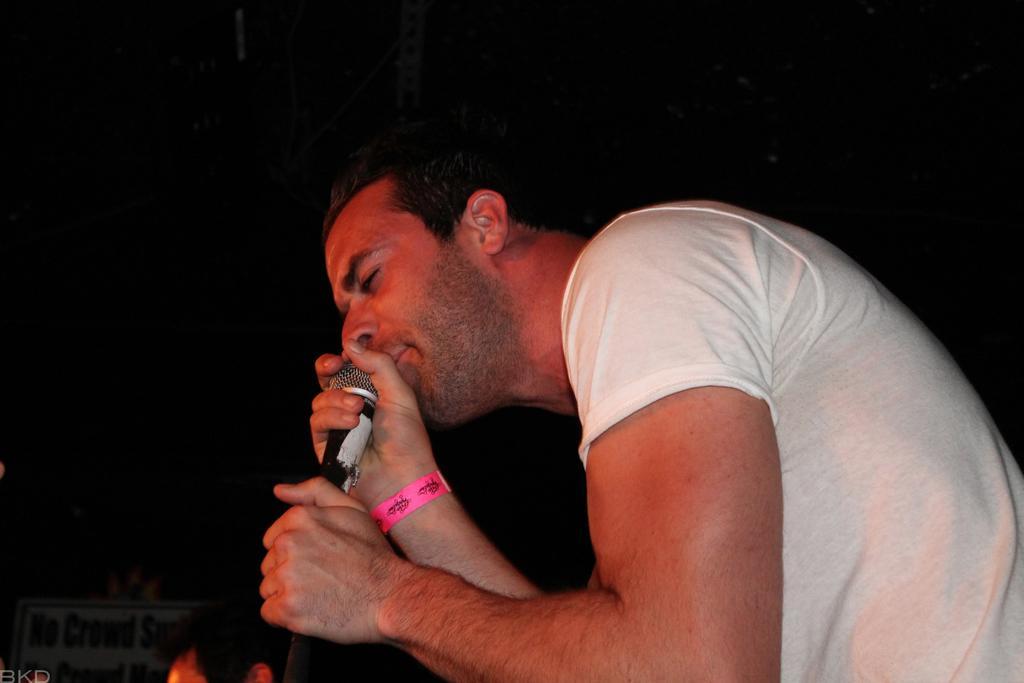How would you summarize this image in a sentence or two? In this image we can see a man. He is wearing a white T-shirt and holding a mic in his hand. The background is dark. We can see a banner and one more person in the left bottom of the image. 